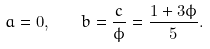<formula> <loc_0><loc_0><loc_500><loc_500>a = 0 , \quad b = \frac { c } { \phi } = \frac { 1 + 3 \phi } 5 .</formula> 